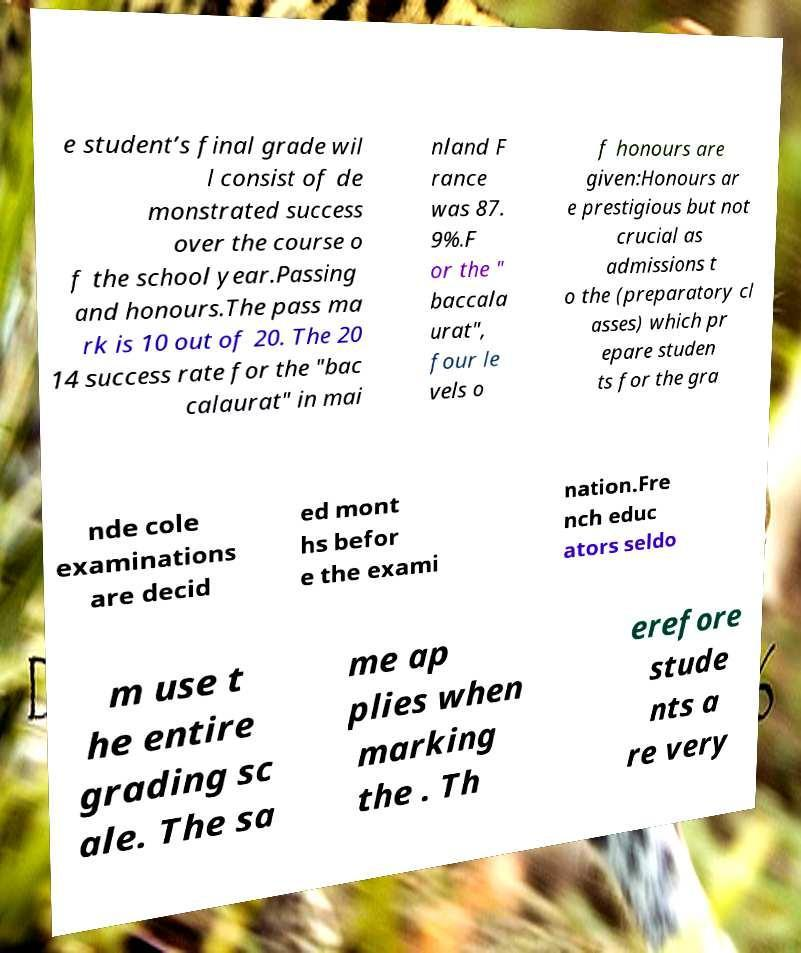What messages or text are displayed in this image? I need them in a readable, typed format. e student’s final grade wil l consist of de monstrated success over the course o f the school year.Passing and honours.The pass ma rk is 10 out of 20. The 20 14 success rate for the "bac calaurat" in mai nland F rance was 87. 9%.F or the " baccala urat", four le vels o f honours are given:Honours ar e prestigious but not crucial as admissions t o the (preparatory cl asses) which pr epare studen ts for the gra nde cole examinations are decid ed mont hs befor e the exami nation.Fre nch educ ators seldo m use t he entire grading sc ale. The sa me ap plies when marking the . Th erefore stude nts a re very 